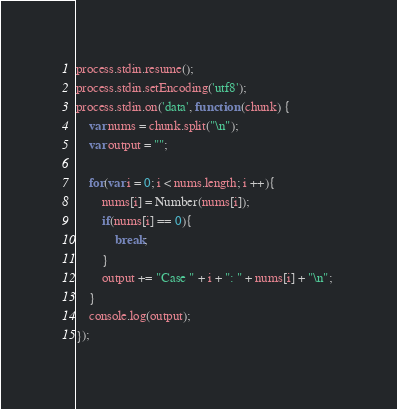<code> <loc_0><loc_0><loc_500><loc_500><_JavaScript_>process.stdin.resume();
process.stdin.setEncoding('utf8');
process.stdin.on('data', function (chunk) {
    var nums = chunk.split("\n");
    var output = "";
    
    for(var i = 0; i < nums.length; i ++){
        nums[i] = Number(nums[i]);
        if(nums[i] == 0){
            break;
        }
        output += "Case " + i + ": " + nums[i] + "\n"; 
    }
    console.log(output);
});</code> 